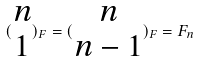Convert formula to latex. <formula><loc_0><loc_0><loc_500><loc_500>( \begin{matrix} n \\ 1 \end{matrix} ) _ { F } = ( \begin{matrix} n \\ n - 1 \end{matrix} ) _ { F } = F _ { n }</formula> 